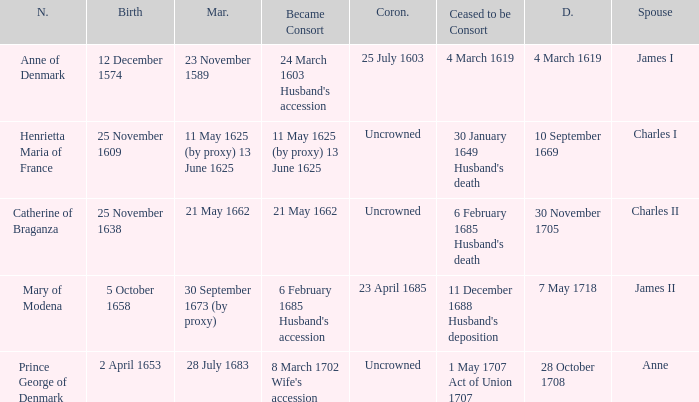When was the date of death for the person married to Charles II? 30 November 1705. Could you parse the entire table? {'header': ['N.', 'Birth', 'Mar.', 'Became Consort', 'Coron.', 'Ceased to be Consort', 'D.', 'Spouse'], 'rows': [['Anne of Denmark', '12 December 1574', '23 November 1589', "24 March 1603 Husband's accession", '25 July 1603', '4 March 1619', '4 March 1619', 'James I'], ['Henrietta Maria of France', '25 November 1609', '11 May 1625 (by proxy) 13 June 1625', '11 May 1625 (by proxy) 13 June 1625', 'Uncrowned', "30 January 1649 Husband's death", '10 September 1669', 'Charles I'], ['Catherine of Braganza', '25 November 1638', '21 May 1662', '21 May 1662', 'Uncrowned', "6 February 1685 Husband's death", '30 November 1705', 'Charles II'], ['Mary of Modena', '5 October 1658', '30 September 1673 (by proxy)', "6 February 1685 Husband's accession", '23 April 1685', "11 December 1688 Husband's deposition", '7 May 1718', 'James II'], ['Prince George of Denmark', '2 April 1653', '28 July 1683', "8 March 1702 Wife's accession", 'Uncrowned', '1 May 1707 Act of Union 1707', '28 October 1708', 'Anne']]} 